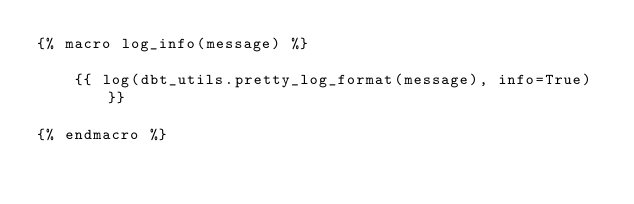<code> <loc_0><loc_0><loc_500><loc_500><_SQL_>{% macro log_info(message) %}

    {{ log(dbt_utils.pretty_log_format(message), info=True) }}

{% endmacro %}
</code> 